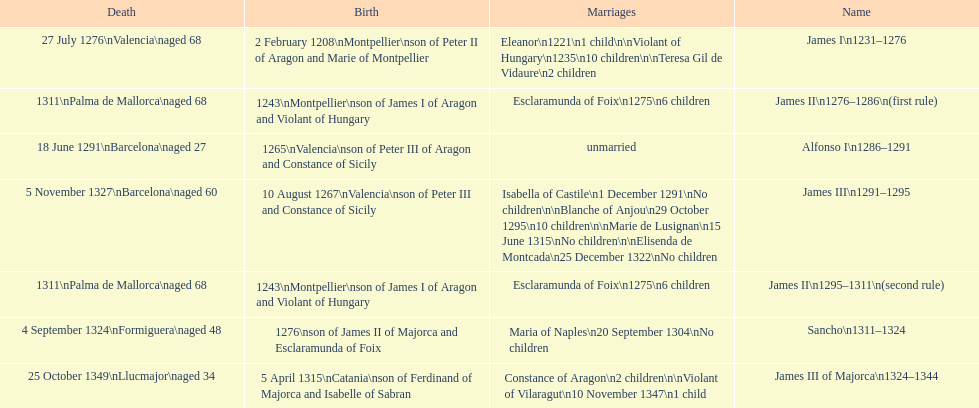What name is above james iii and below james ii? Alfonso I. 